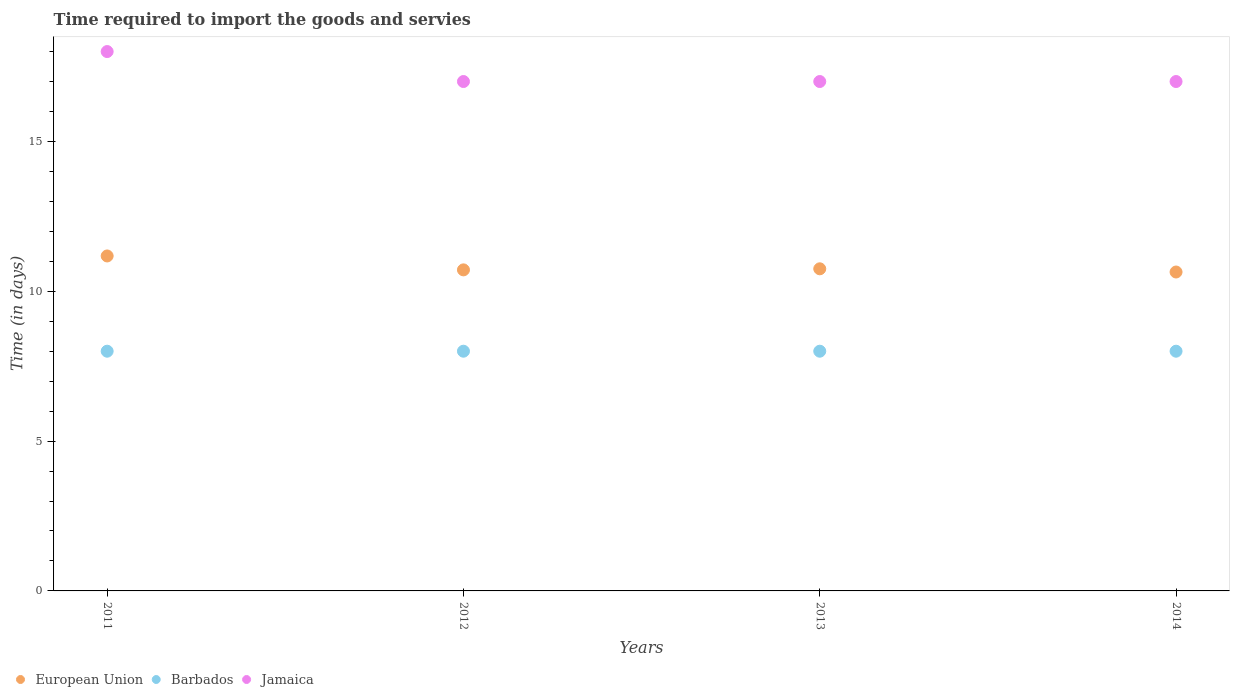What is the number of days required to import the goods and services in Barbados in 2013?
Keep it short and to the point. 8. Across all years, what is the maximum number of days required to import the goods and services in European Union?
Provide a short and direct response. 11.18. Across all years, what is the minimum number of days required to import the goods and services in Barbados?
Offer a terse response. 8. In which year was the number of days required to import the goods and services in Jamaica maximum?
Keep it short and to the point. 2011. What is the total number of days required to import the goods and services in European Union in the graph?
Keep it short and to the point. 43.29. What is the difference between the number of days required to import the goods and services in Jamaica in 2011 and the number of days required to import the goods and services in European Union in 2012?
Offer a very short reply. 7.29. In the year 2014, what is the difference between the number of days required to import the goods and services in Jamaica and number of days required to import the goods and services in Barbados?
Ensure brevity in your answer.  9. What is the ratio of the number of days required to import the goods and services in Jamaica in 2011 to that in 2013?
Give a very brief answer. 1.06. Is the number of days required to import the goods and services in Barbados in 2011 less than that in 2012?
Your response must be concise. No. Is the difference between the number of days required to import the goods and services in Jamaica in 2011 and 2013 greater than the difference between the number of days required to import the goods and services in Barbados in 2011 and 2013?
Offer a terse response. Yes. What is the difference between the highest and the second highest number of days required to import the goods and services in Jamaica?
Give a very brief answer. 1. What is the difference between the highest and the lowest number of days required to import the goods and services in European Union?
Provide a short and direct response. 0.54. Is it the case that in every year, the sum of the number of days required to import the goods and services in European Union and number of days required to import the goods and services in Jamaica  is greater than the number of days required to import the goods and services in Barbados?
Ensure brevity in your answer.  Yes. Is the number of days required to import the goods and services in Barbados strictly greater than the number of days required to import the goods and services in Jamaica over the years?
Offer a terse response. No. How many years are there in the graph?
Give a very brief answer. 4. Does the graph contain any zero values?
Your response must be concise. No. Does the graph contain grids?
Offer a terse response. No. Where does the legend appear in the graph?
Make the answer very short. Bottom left. How are the legend labels stacked?
Your answer should be very brief. Horizontal. What is the title of the graph?
Provide a succinct answer. Time required to import the goods and servies. Does "Slovak Republic" appear as one of the legend labels in the graph?
Your response must be concise. No. What is the label or title of the Y-axis?
Ensure brevity in your answer.  Time (in days). What is the Time (in days) in European Union in 2011?
Your answer should be very brief. 11.18. What is the Time (in days) in Barbados in 2011?
Provide a short and direct response. 8. What is the Time (in days) in European Union in 2012?
Your response must be concise. 10.71. What is the Time (in days) in Jamaica in 2012?
Ensure brevity in your answer.  17. What is the Time (in days) of European Union in 2013?
Provide a short and direct response. 10.75. What is the Time (in days) in Barbados in 2013?
Your response must be concise. 8. What is the Time (in days) in European Union in 2014?
Your response must be concise. 10.64. What is the Time (in days) of Barbados in 2014?
Give a very brief answer. 8. Across all years, what is the maximum Time (in days) of European Union?
Provide a short and direct response. 11.18. Across all years, what is the maximum Time (in days) of Barbados?
Ensure brevity in your answer.  8. Across all years, what is the maximum Time (in days) in Jamaica?
Offer a very short reply. 18. Across all years, what is the minimum Time (in days) of European Union?
Ensure brevity in your answer.  10.64. Across all years, what is the minimum Time (in days) in Barbados?
Make the answer very short. 8. What is the total Time (in days) of European Union in the graph?
Offer a terse response. 43.29. What is the difference between the Time (in days) of European Union in 2011 and that in 2012?
Ensure brevity in your answer.  0.46. What is the difference between the Time (in days) of Jamaica in 2011 and that in 2012?
Provide a succinct answer. 1. What is the difference between the Time (in days) in European Union in 2011 and that in 2013?
Ensure brevity in your answer.  0.43. What is the difference between the Time (in days) of Jamaica in 2011 and that in 2013?
Your answer should be very brief. 1. What is the difference between the Time (in days) of European Union in 2011 and that in 2014?
Provide a short and direct response. 0.54. What is the difference between the Time (in days) of Barbados in 2011 and that in 2014?
Your answer should be very brief. 0. What is the difference between the Time (in days) in European Union in 2012 and that in 2013?
Your answer should be very brief. -0.04. What is the difference between the Time (in days) in European Union in 2012 and that in 2014?
Your answer should be compact. 0.07. What is the difference between the Time (in days) in Barbados in 2012 and that in 2014?
Offer a very short reply. 0. What is the difference between the Time (in days) of European Union in 2013 and that in 2014?
Provide a short and direct response. 0.11. What is the difference between the Time (in days) in European Union in 2011 and the Time (in days) in Barbados in 2012?
Ensure brevity in your answer.  3.18. What is the difference between the Time (in days) of European Union in 2011 and the Time (in days) of Jamaica in 2012?
Your response must be concise. -5.82. What is the difference between the Time (in days) of European Union in 2011 and the Time (in days) of Barbados in 2013?
Make the answer very short. 3.18. What is the difference between the Time (in days) in European Union in 2011 and the Time (in days) in Jamaica in 2013?
Offer a very short reply. -5.82. What is the difference between the Time (in days) in European Union in 2011 and the Time (in days) in Barbados in 2014?
Give a very brief answer. 3.18. What is the difference between the Time (in days) of European Union in 2011 and the Time (in days) of Jamaica in 2014?
Your response must be concise. -5.82. What is the difference between the Time (in days) in Barbados in 2011 and the Time (in days) in Jamaica in 2014?
Your answer should be compact. -9. What is the difference between the Time (in days) in European Union in 2012 and the Time (in days) in Barbados in 2013?
Your answer should be very brief. 2.71. What is the difference between the Time (in days) in European Union in 2012 and the Time (in days) in Jamaica in 2013?
Keep it short and to the point. -6.29. What is the difference between the Time (in days) of Barbados in 2012 and the Time (in days) of Jamaica in 2013?
Keep it short and to the point. -9. What is the difference between the Time (in days) in European Union in 2012 and the Time (in days) in Barbados in 2014?
Make the answer very short. 2.71. What is the difference between the Time (in days) in European Union in 2012 and the Time (in days) in Jamaica in 2014?
Ensure brevity in your answer.  -6.29. What is the difference between the Time (in days) in Barbados in 2012 and the Time (in days) in Jamaica in 2014?
Give a very brief answer. -9. What is the difference between the Time (in days) of European Union in 2013 and the Time (in days) of Barbados in 2014?
Keep it short and to the point. 2.75. What is the difference between the Time (in days) in European Union in 2013 and the Time (in days) in Jamaica in 2014?
Provide a succinct answer. -6.25. What is the difference between the Time (in days) of Barbados in 2013 and the Time (in days) of Jamaica in 2014?
Give a very brief answer. -9. What is the average Time (in days) of European Union per year?
Your response must be concise. 10.82. What is the average Time (in days) of Jamaica per year?
Your answer should be compact. 17.25. In the year 2011, what is the difference between the Time (in days) in European Union and Time (in days) in Barbados?
Give a very brief answer. 3.18. In the year 2011, what is the difference between the Time (in days) of European Union and Time (in days) of Jamaica?
Offer a very short reply. -6.82. In the year 2011, what is the difference between the Time (in days) in Barbados and Time (in days) in Jamaica?
Offer a very short reply. -10. In the year 2012, what is the difference between the Time (in days) in European Union and Time (in days) in Barbados?
Provide a short and direct response. 2.71. In the year 2012, what is the difference between the Time (in days) of European Union and Time (in days) of Jamaica?
Provide a succinct answer. -6.29. In the year 2012, what is the difference between the Time (in days) of Barbados and Time (in days) of Jamaica?
Ensure brevity in your answer.  -9. In the year 2013, what is the difference between the Time (in days) of European Union and Time (in days) of Barbados?
Offer a terse response. 2.75. In the year 2013, what is the difference between the Time (in days) of European Union and Time (in days) of Jamaica?
Your answer should be compact. -6.25. In the year 2014, what is the difference between the Time (in days) of European Union and Time (in days) of Barbados?
Keep it short and to the point. 2.64. In the year 2014, what is the difference between the Time (in days) of European Union and Time (in days) of Jamaica?
Offer a terse response. -6.36. What is the ratio of the Time (in days) of European Union in 2011 to that in 2012?
Your response must be concise. 1.04. What is the ratio of the Time (in days) in Barbados in 2011 to that in 2012?
Offer a terse response. 1. What is the ratio of the Time (in days) in Jamaica in 2011 to that in 2012?
Your response must be concise. 1.06. What is the ratio of the Time (in days) in European Union in 2011 to that in 2013?
Offer a terse response. 1.04. What is the ratio of the Time (in days) of Jamaica in 2011 to that in 2013?
Ensure brevity in your answer.  1.06. What is the ratio of the Time (in days) of European Union in 2011 to that in 2014?
Provide a short and direct response. 1.05. What is the ratio of the Time (in days) of Barbados in 2011 to that in 2014?
Ensure brevity in your answer.  1. What is the ratio of the Time (in days) in Jamaica in 2011 to that in 2014?
Provide a succinct answer. 1.06. What is the ratio of the Time (in days) of Barbados in 2012 to that in 2013?
Your response must be concise. 1. What is the ratio of the Time (in days) in Jamaica in 2012 to that in 2013?
Your answer should be very brief. 1. What is the ratio of the Time (in days) in Barbados in 2012 to that in 2014?
Your response must be concise. 1. What is the ratio of the Time (in days) in Jamaica in 2012 to that in 2014?
Provide a succinct answer. 1. What is the ratio of the Time (in days) in European Union in 2013 to that in 2014?
Ensure brevity in your answer.  1.01. What is the difference between the highest and the second highest Time (in days) of European Union?
Your answer should be very brief. 0.43. What is the difference between the highest and the lowest Time (in days) in European Union?
Provide a short and direct response. 0.54. What is the difference between the highest and the lowest Time (in days) of Barbados?
Ensure brevity in your answer.  0. 